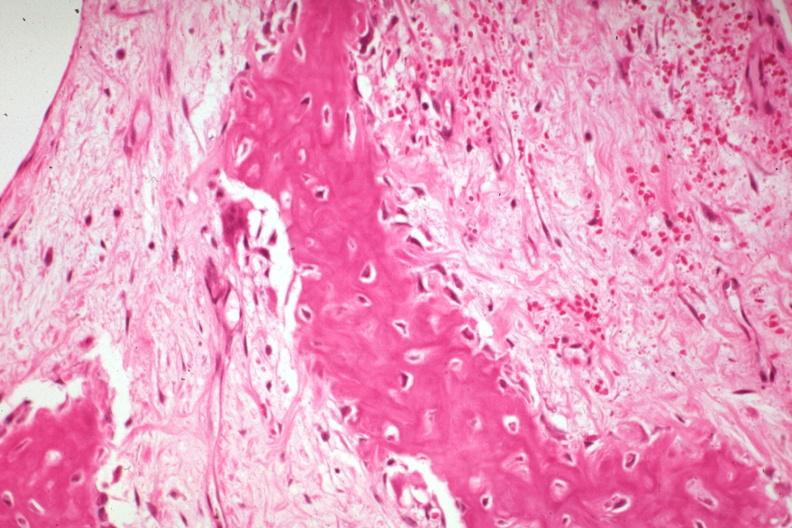what is present?
Answer the question using a single word or phrase. Joints 